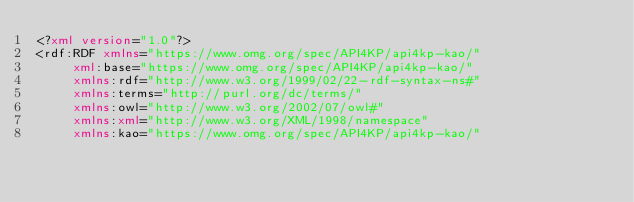<code> <loc_0><loc_0><loc_500><loc_500><_XML_><?xml version="1.0"?>
<rdf:RDF xmlns="https://www.omg.org/spec/API4KP/api4kp-kao/"
     xml:base="https://www.omg.org/spec/API4KP/api4kp-kao/"
     xmlns:rdf="http://www.w3.org/1999/02/22-rdf-syntax-ns#"
     xmlns:terms="http://purl.org/dc/terms/"
     xmlns:owl="http://www.w3.org/2002/07/owl#"
     xmlns:xml="http://www.w3.org/XML/1998/namespace"
     xmlns:kao="https://www.omg.org/spec/API4KP/api4kp-kao/"</code> 